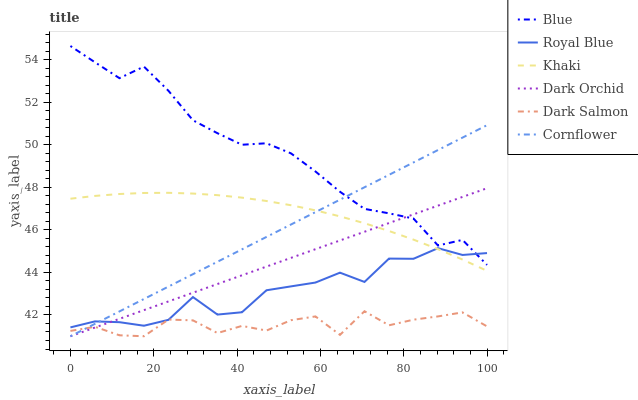Does Cornflower have the minimum area under the curve?
Answer yes or no. No. Does Cornflower have the maximum area under the curve?
Answer yes or no. No. Is Khaki the smoothest?
Answer yes or no. No. Is Khaki the roughest?
Answer yes or no. No. Does Khaki have the lowest value?
Answer yes or no. No. Does Cornflower have the highest value?
Answer yes or no. No. Is Dark Salmon less than Khaki?
Answer yes or no. Yes. Is Blue greater than Khaki?
Answer yes or no. Yes. Does Dark Salmon intersect Khaki?
Answer yes or no. No. 